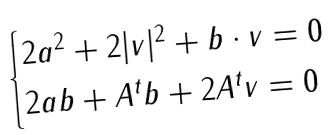Convert formula to latex. <formula><loc_0><loc_0><loc_500><loc_500>\begin{cases} 2 a ^ { 2 } + 2 | v | ^ { 2 } + b \cdot v = 0 \\ 2 a b + A ^ { t } b + 2 A ^ { t } v = 0 \end{cases}</formula> 